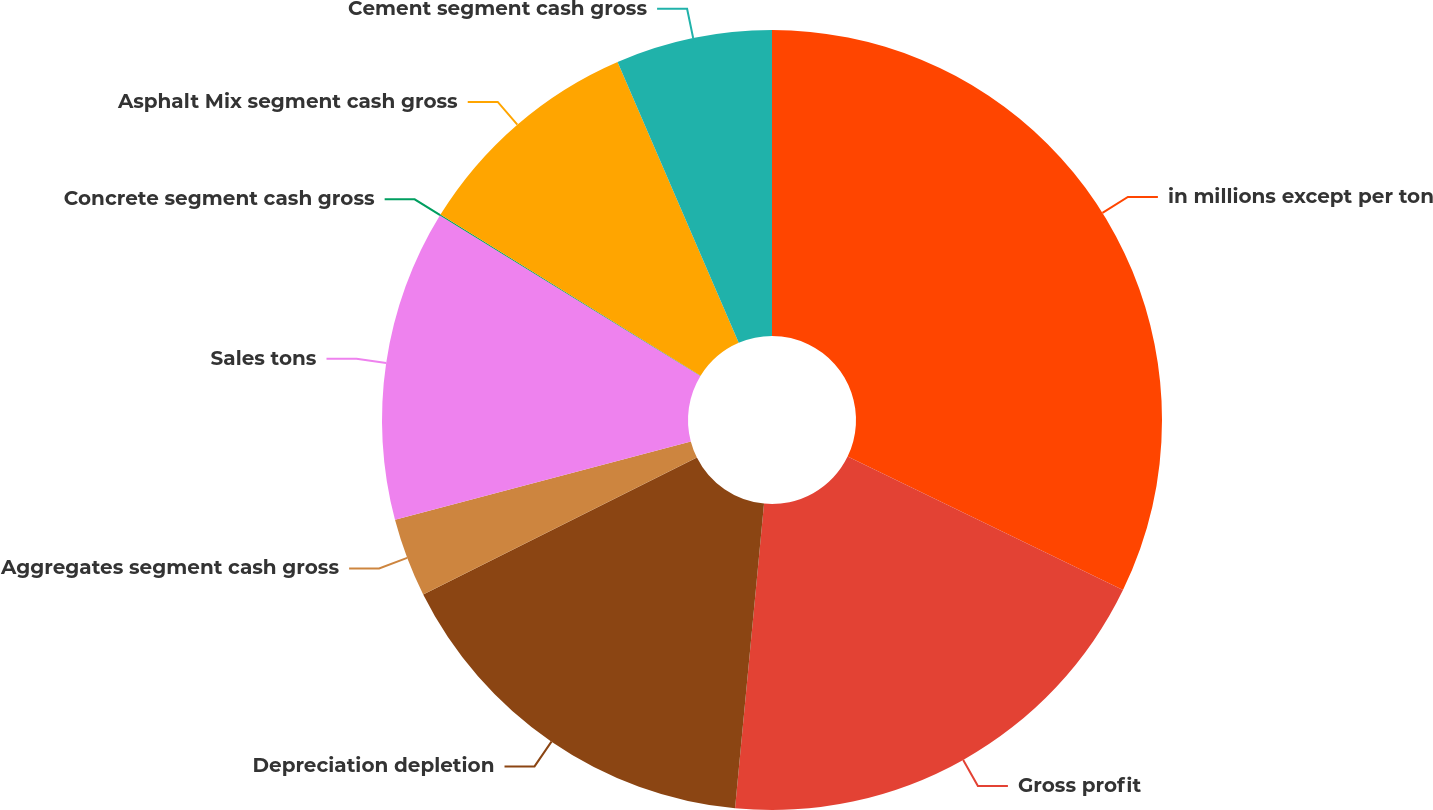Convert chart to OTSL. <chart><loc_0><loc_0><loc_500><loc_500><pie_chart><fcel>in millions except per ton<fcel>Gross profit<fcel>Depreciation depletion<fcel>Aggregates segment cash gross<fcel>Sales tons<fcel>Concrete segment cash gross<fcel>Asphalt Mix segment cash gross<fcel>Cement segment cash gross<nl><fcel>32.18%<fcel>19.33%<fcel>16.11%<fcel>3.26%<fcel>12.9%<fcel>0.05%<fcel>9.69%<fcel>6.48%<nl></chart> 